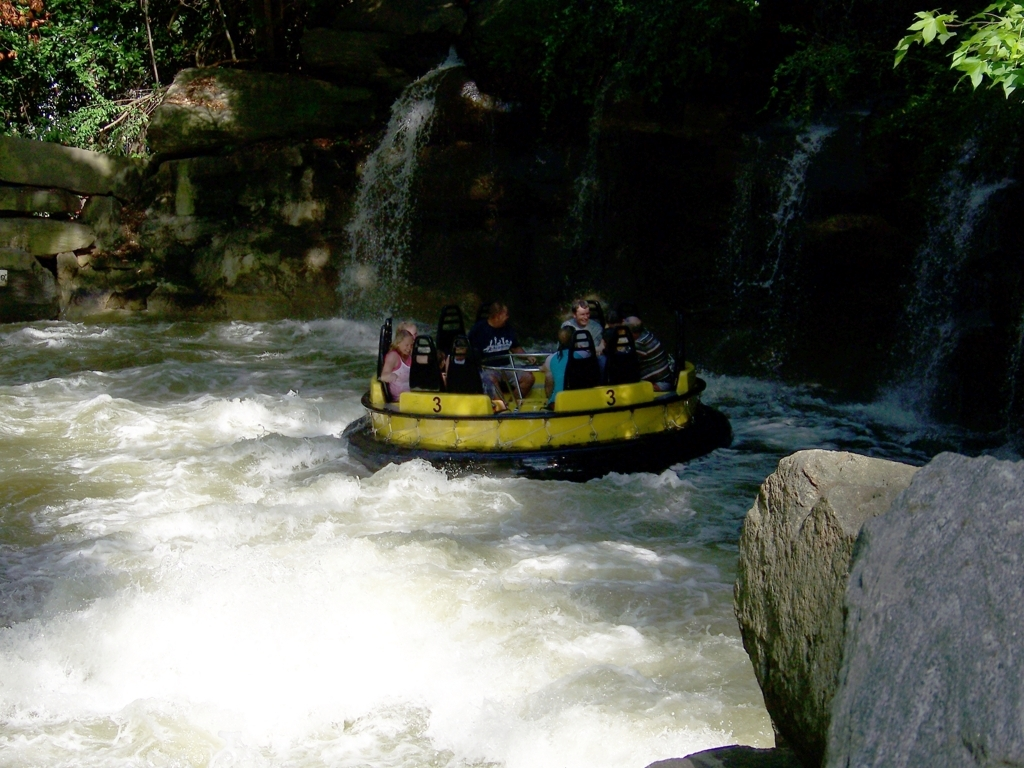Can you tell if the people are wearing safety equipment? Yes, safety appears to be a priority in this adventure. The occupants of the raft are equipped with life jackets, which are essential personal flotation devices for water activities. These jackets provide buoyancy and help keep the wearers afloat in case they find themselves in the water. 